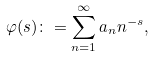Convert formula to latex. <formula><loc_0><loc_0><loc_500><loc_500>\varphi ( s ) \colon = \sum _ { n = 1 } ^ { \infty } a _ { n } n ^ { - s } ,</formula> 